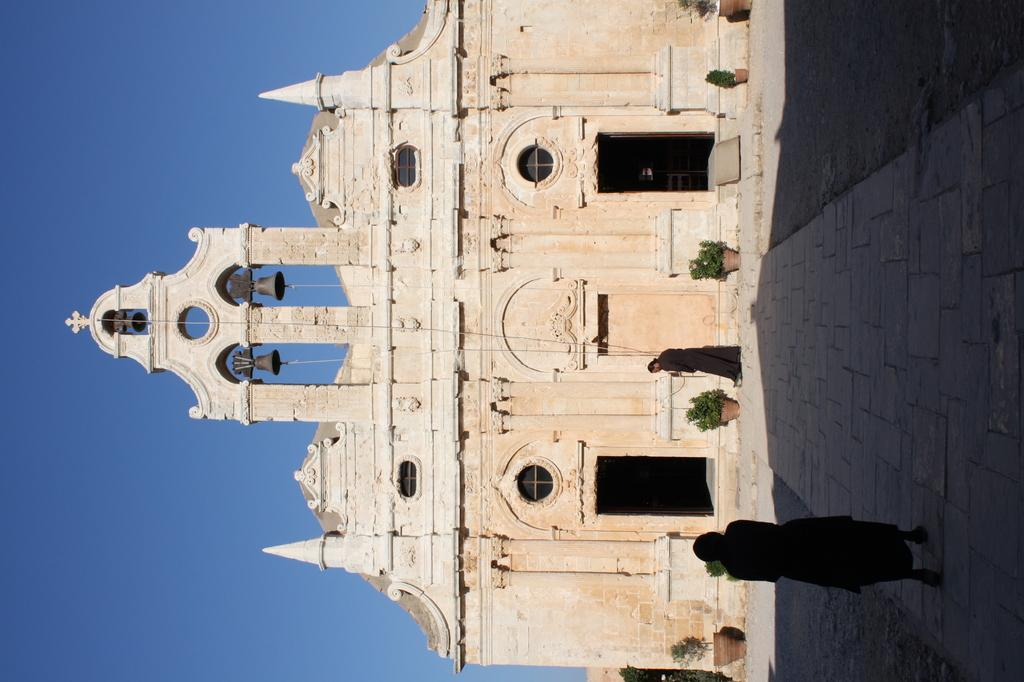How many people are in the foreground of the image? There are two people standing in the foreground of the image. What surface are the people standing on? The people are standing on a pavement. What other objects can be seen in the image? There are posts visible in the image. What type of structure is present in the image? There is a building in the image. What is visible in the background of the image? The sky is visible in the image. How many rabbits are hopping around the people in the image? There are no rabbits present in the image. What color is the sweater worn by the person on the left? The provided facts do not mention any clothing or colors, so we cannot determine the color of a sweater worn by the person on the left. 